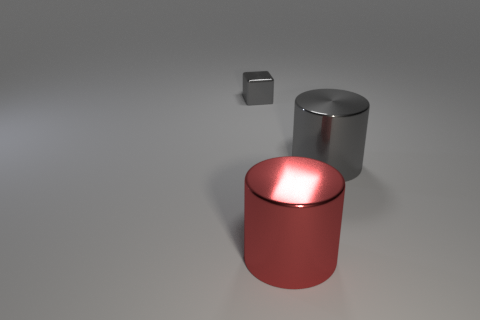What's the texture like on the red object? The red object has a matte finish which diffuses light evenly across its surface, giving it an even and tactile texture. Could you guess what material the red object is made from? Although the specific material isn't clear from the image, the red object's matte texture and solid appearance suggest it could be made of a painted metal or a high-grade plastic. 